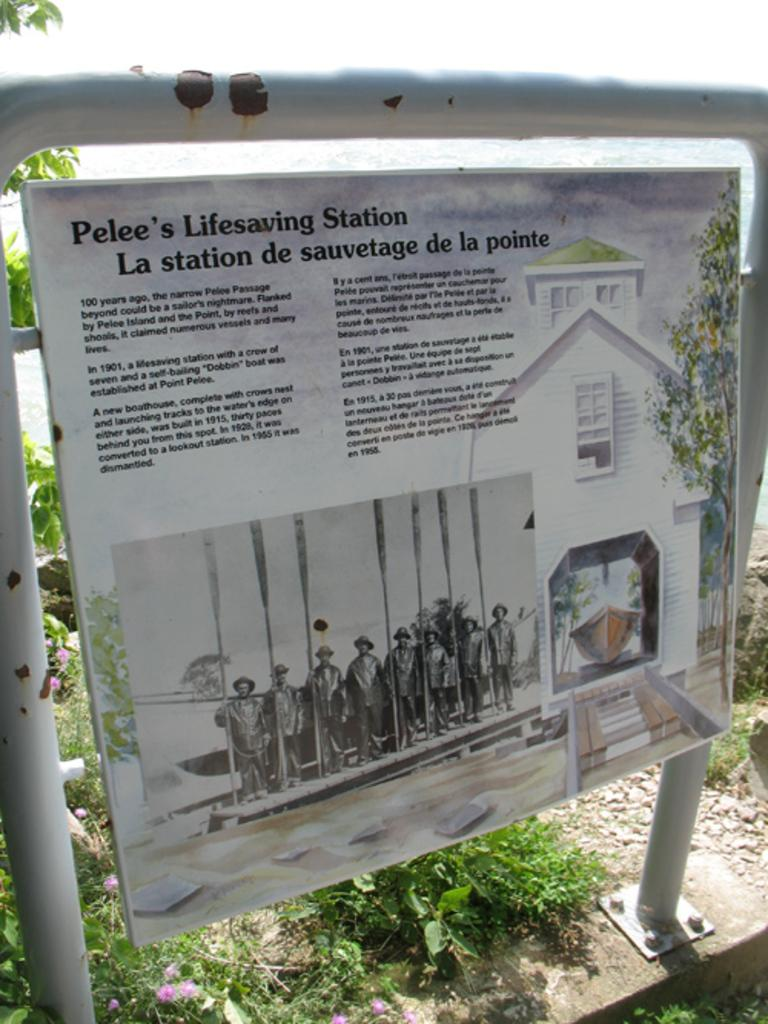What is attached to the pole in the image? There is a board attached to a pole in the image. What can be seen in the background of the image? There are plants visible in the background of the image. What type of cart is being used in the war depicted in the image? There is no war or cart present in the image; it only features a board attached to a pole and plants in the background. 